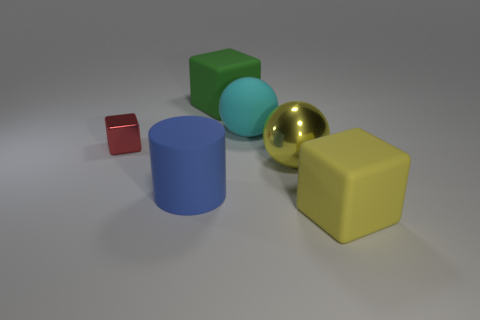Is the shape of the large green rubber object the same as the small red metal object?
Provide a succinct answer. Yes. Is the number of cyan objects that are to the left of the blue thing less than the number of big brown metallic cylinders?
Make the answer very short. No. The big matte block that is right of the yellow thing behind the rubber block on the right side of the big metallic thing is what color?
Offer a terse response. Yellow. How many rubber things are either cyan objects or large cubes?
Your response must be concise. 3. Is the matte ball the same size as the yellow cube?
Offer a very short reply. Yes. Is the number of big blue objects that are to the left of the small shiny cube less than the number of cyan objects in front of the big green matte object?
Ensure brevity in your answer.  Yes. Is there anything else that has the same size as the red metal thing?
Offer a terse response. No. What is the size of the cylinder?
Provide a succinct answer. Large. How many large objects are either blue cylinders or green blocks?
Offer a very short reply. 2. There is a cyan matte sphere; is it the same size as the metallic object that is to the left of the green matte thing?
Make the answer very short. No. 